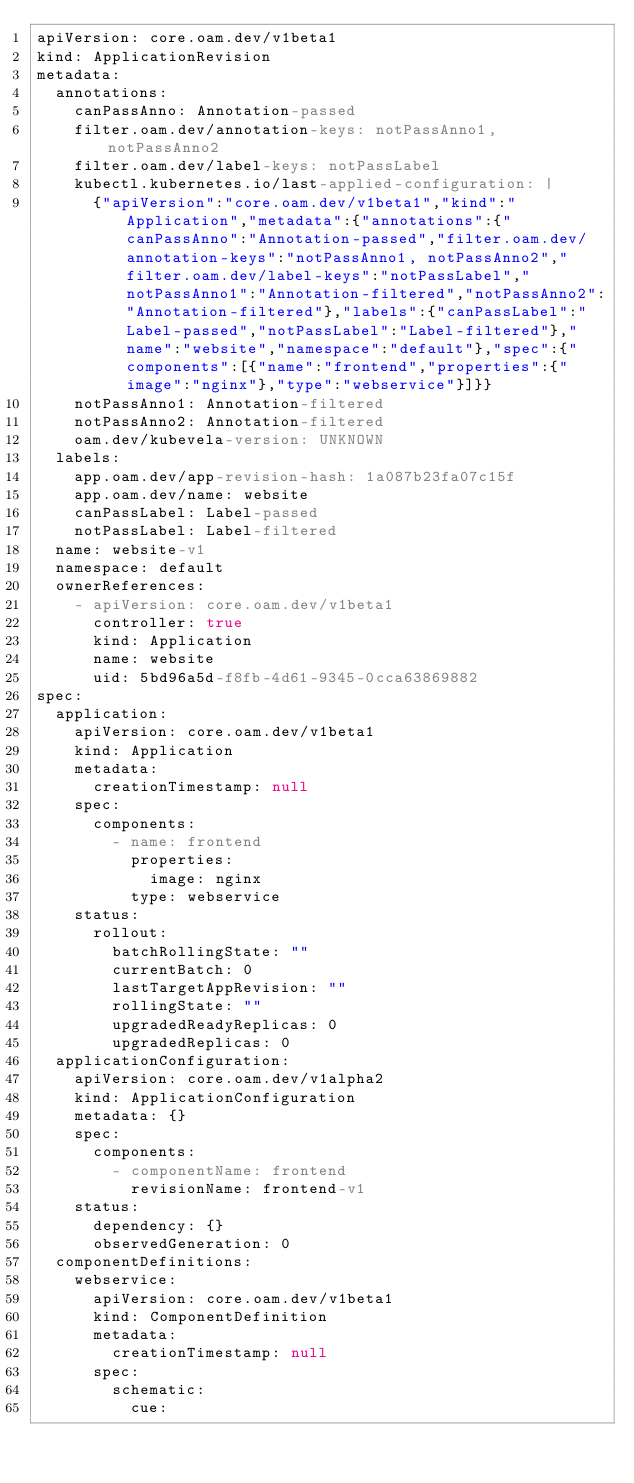Convert code to text. <code><loc_0><loc_0><loc_500><loc_500><_YAML_>apiVersion: core.oam.dev/v1beta1
kind: ApplicationRevision
metadata:
  annotations:
    canPassAnno: Annotation-passed
    filter.oam.dev/annotation-keys: notPassAnno1, notPassAnno2
    filter.oam.dev/label-keys: notPassLabel
    kubectl.kubernetes.io/last-applied-configuration: |
      {"apiVersion":"core.oam.dev/v1beta1","kind":"Application","metadata":{"annotations":{"canPassAnno":"Annotation-passed","filter.oam.dev/annotation-keys":"notPassAnno1, notPassAnno2","filter.oam.dev/label-keys":"notPassLabel","notPassAnno1":"Annotation-filtered","notPassAnno2":"Annotation-filtered"},"labels":{"canPassLabel":"Label-passed","notPassLabel":"Label-filtered"},"name":"website","namespace":"default"},"spec":{"components":[{"name":"frontend","properties":{"image":"nginx"},"type":"webservice"}]}}
    notPassAnno1: Annotation-filtered
    notPassAnno2: Annotation-filtered
    oam.dev/kubevela-version: UNKNOWN
  labels:
    app.oam.dev/app-revision-hash: 1a087b23fa07c15f
    app.oam.dev/name: website
    canPassLabel: Label-passed
    notPassLabel: Label-filtered
  name: website-v1
  namespace: default
  ownerReferences:
    - apiVersion: core.oam.dev/v1beta1
      controller: true
      kind: Application
      name: website
      uid: 5bd96a5d-f8fb-4d61-9345-0cca63869882
spec:
  application:
    apiVersion: core.oam.dev/v1beta1
    kind: Application
    metadata:
      creationTimestamp: null
    spec:
      components:
        - name: frontend
          properties:
            image: nginx
          type: webservice
    status:
      rollout:
        batchRollingState: ""
        currentBatch: 0
        lastTargetAppRevision: ""
        rollingState: ""
        upgradedReadyReplicas: 0
        upgradedReplicas: 0
  applicationConfiguration:
    apiVersion: core.oam.dev/v1alpha2
    kind: ApplicationConfiguration
    metadata: {}
    spec:
      components:
        - componentName: frontend
          revisionName: frontend-v1
    status:
      dependency: {}
      observedGeneration: 0
  componentDefinitions:
    webservice:
      apiVersion: core.oam.dev/v1beta1
      kind: ComponentDefinition
      metadata:
        creationTimestamp: null
      spec:
        schematic:
          cue:</code> 